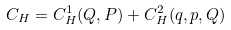<formula> <loc_0><loc_0><loc_500><loc_500>C _ { H } = C _ { H } ^ { 1 } ( Q , P ) + C _ { H } ^ { 2 } ( q , p , Q )</formula> 